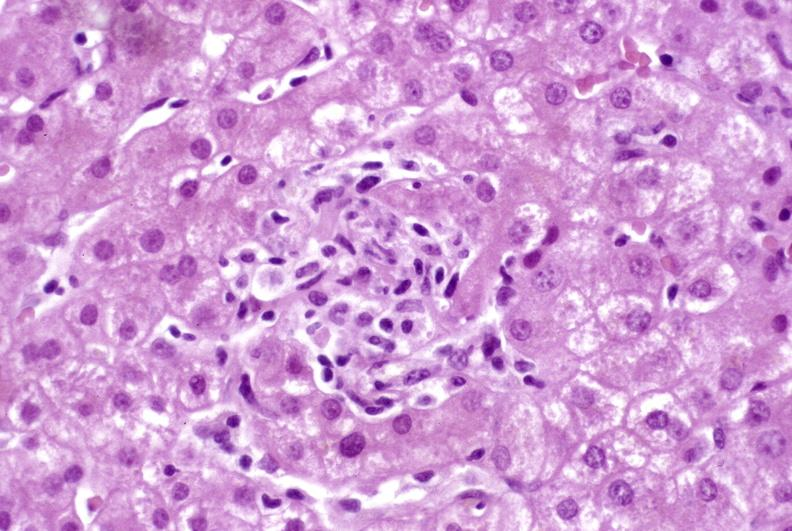does this image show granulomas?
Answer the question using a single word or phrase. Yes 